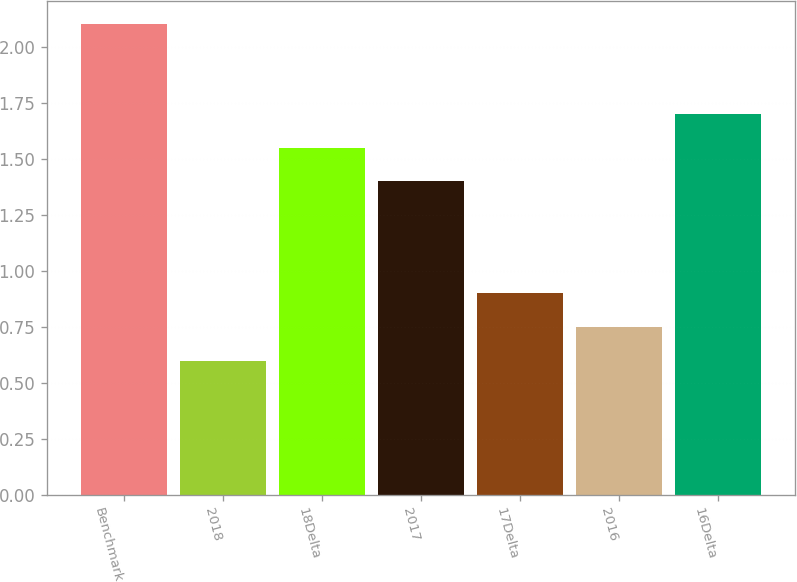Convert chart. <chart><loc_0><loc_0><loc_500><loc_500><bar_chart><fcel>Benchmark<fcel>2018<fcel>18Delta<fcel>2017<fcel>17Delta<fcel>2016<fcel>16Delta<nl><fcel>2.1<fcel>0.6<fcel>1.55<fcel>1.4<fcel>0.9<fcel>0.75<fcel>1.7<nl></chart> 